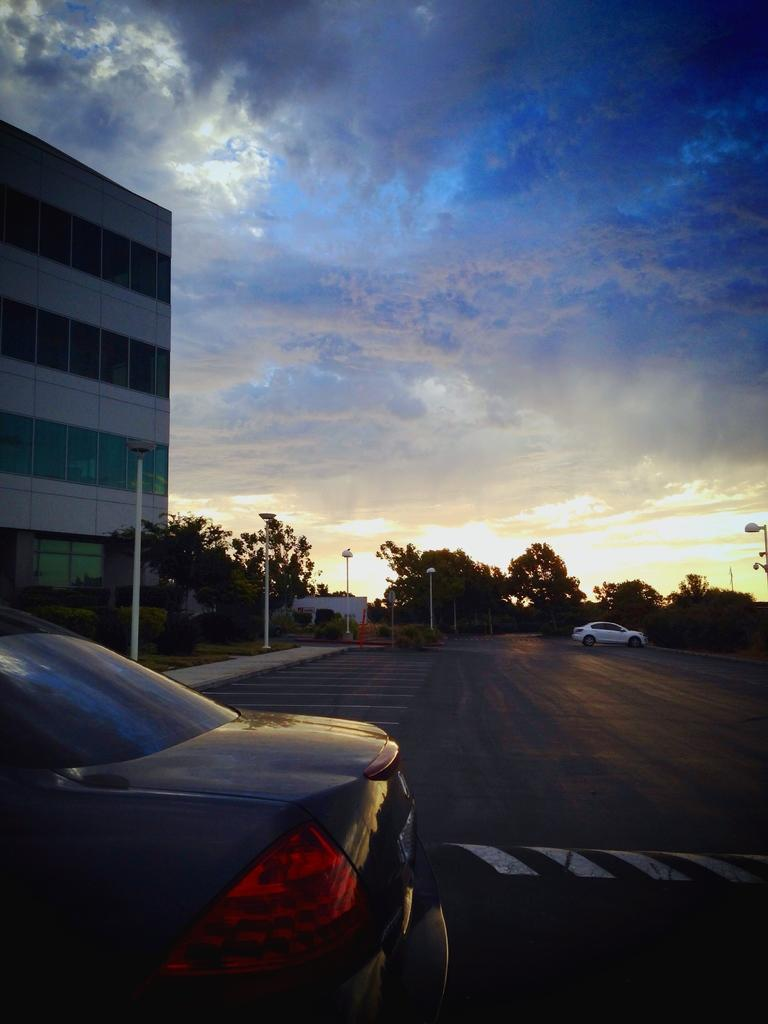What can be seen on the road in the image? There are vehicles on the road in the image. What type of vegetation is visible in the image? There is grass visible in the image. What type of structure can be seen in the image? There is at least one building in the image. What are the tall, thin objects in the image? There are poles in the image. What other natural elements are present in the image? There are trees in the image. What is visible in the background of the image? The sky with clouds is visible in the background of the image. What type of teaching is happening in the image? There is no teaching activity depicted in the image. Can you see a turkey in the image? There is no turkey present in the image. 